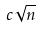Convert formula to latex. <formula><loc_0><loc_0><loc_500><loc_500>c \sqrt { n }</formula> 